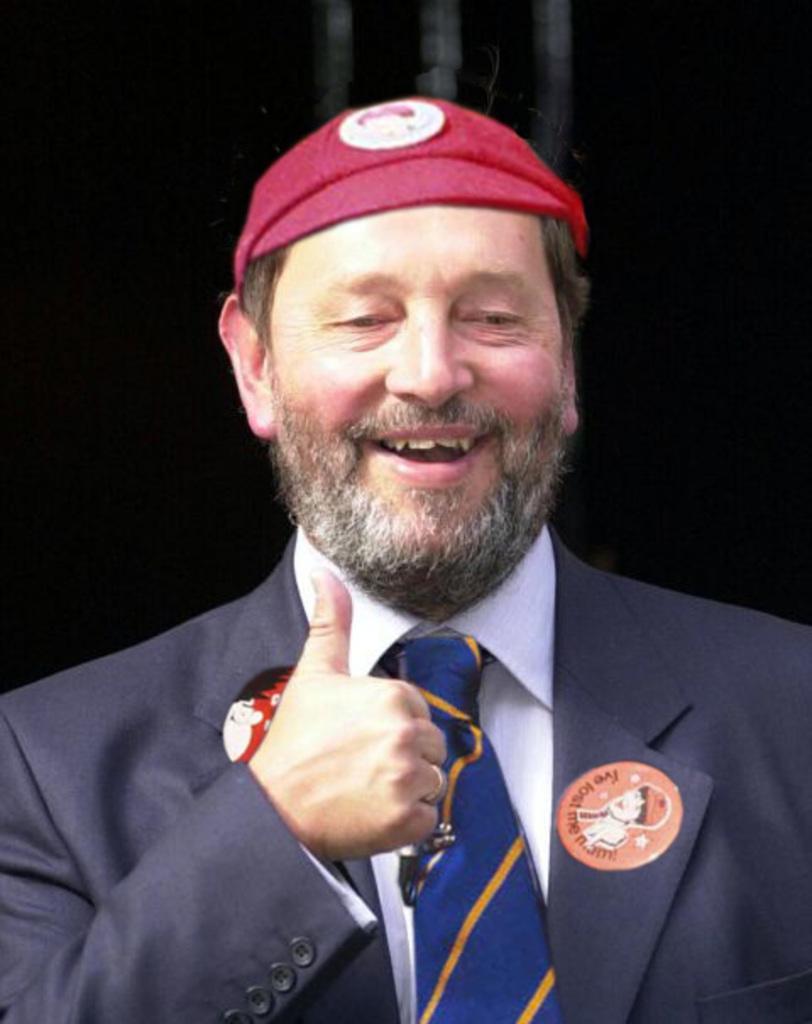Please provide a concise description of this image. As we can see in the image in the front there is a man wearing red color cap, red color suit and the background is dark. 